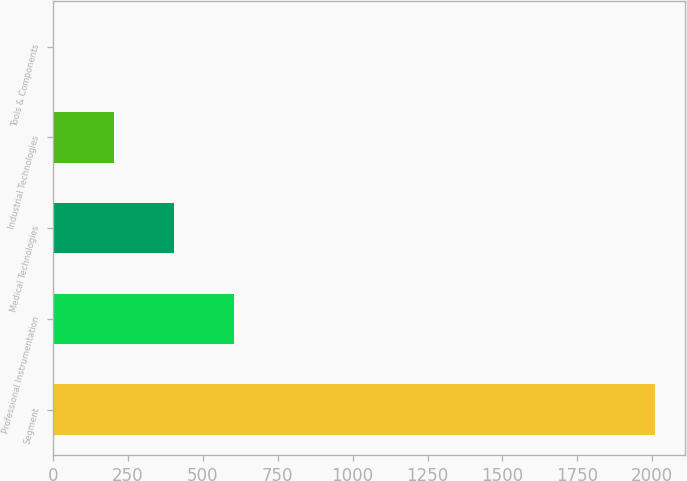Convert chart to OTSL. <chart><loc_0><loc_0><loc_500><loc_500><bar_chart><fcel>Segment<fcel>Professional Instrumentation<fcel>Medical Technologies<fcel>Industrial Technologies<fcel>Tools & Components<nl><fcel>2008<fcel>605.2<fcel>404.8<fcel>204.4<fcel>4<nl></chart> 